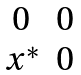Convert formula to latex. <formula><loc_0><loc_0><loc_500><loc_500>\begin{matrix} 0 & 0 \\ x ^ { * } & 0 \end{matrix}</formula> 